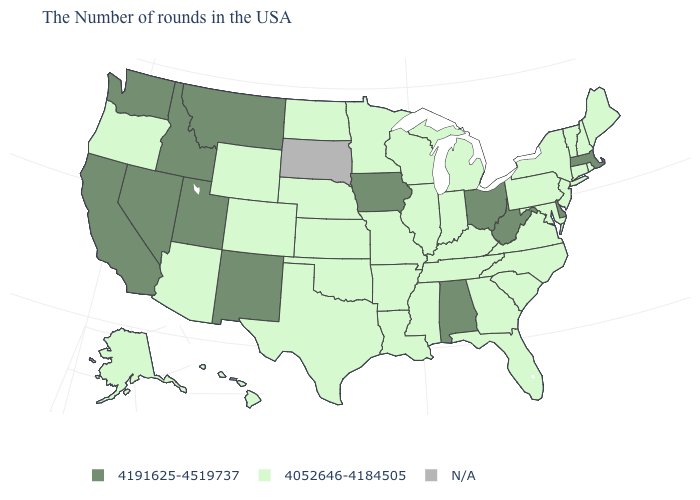What is the value of Wyoming?
Short answer required. 4052646-4184505. What is the value of Illinois?
Be succinct. 4052646-4184505. Name the states that have a value in the range 4052646-4184505?
Write a very short answer. Maine, Rhode Island, New Hampshire, Vermont, Connecticut, New York, New Jersey, Maryland, Pennsylvania, Virginia, North Carolina, South Carolina, Florida, Georgia, Michigan, Kentucky, Indiana, Tennessee, Wisconsin, Illinois, Mississippi, Louisiana, Missouri, Arkansas, Minnesota, Kansas, Nebraska, Oklahoma, Texas, North Dakota, Wyoming, Colorado, Arizona, Oregon, Alaska, Hawaii. Name the states that have a value in the range 4191625-4519737?
Be succinct. Massachusetts, Delaware, West Virginia, Ohio, Alabama, Iowa, New Mexico, Utah, Montana, Idaho, Nevada, California, Washington. Is the legend a continuous bar?
Short answer required. No. Is the legend a continuous bar?
Short answer required. No. What is the value of Louisiana?
Keep it brief. 4052646-4184505. What is the value of Montana?
Write a very short answer. 4191625-4519737. Among the states that border Tennessee , which have the lowest value?
Concise answer only. Virginia, North Carolina, Georgia, Kentucky, Mississippi, Missouri, Arkansas. Among the states that border North Dakota , which have the lowest value?
Give a very brief answer. Minnesota. Name the states that have a value in the range 4191625-4519737?
Quick response, please. Massachusetts, Delaware, West Virginia, Ohio, Alabama, Iowa, New Mexico, Utah, Montana, Idaho, Nevada, California, Washington. Name the states that have a value in the range 4191625-4519737?
Write a very short answer. Massachusetts, Delaware, West Virginia, Ohio, Alabama, Iowa, New Mexico, Utah, Montana, Idaho, Nevada, California, Washington. What is the highest value in the USA?
Concise answer only. 4191625-4519737. Among the states that border Michigan , does Ohio have the lowest value?
Be succinct. No. 